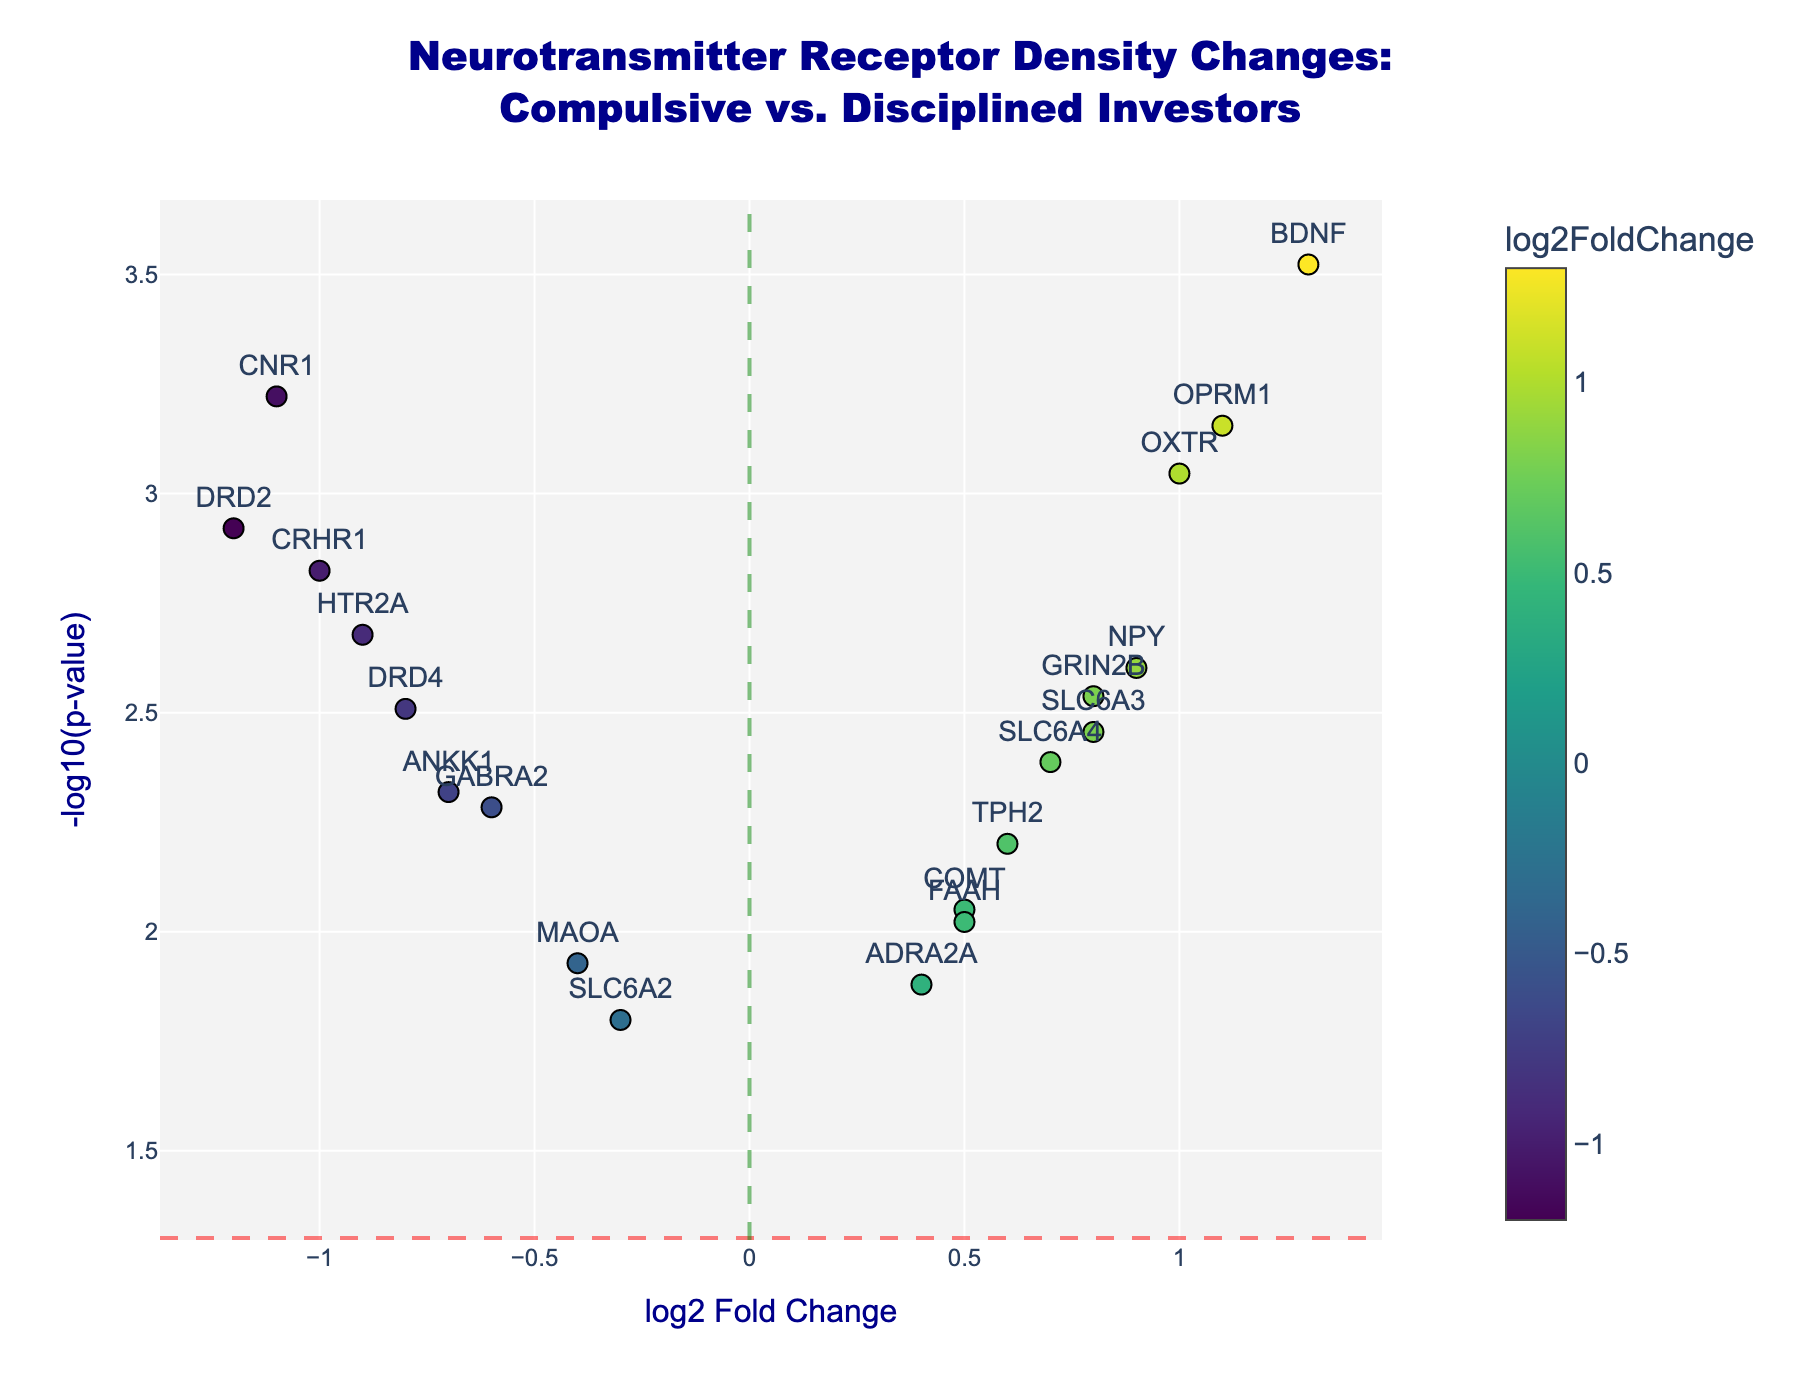What is the title of the figure? The title is stated at the top and is clearly visible. It reads: "Neurotransmitter Receptor Density Changes: Compulsive vs. Disciplined Investors."
Answer: Neurotransmitter Receptor Density Changes: Compulsive vs. Disciplined Investors Which axis represents the log2 Fold Change? The x-axis is labeled as "log2 Fold Change," indicating it represents this value.
Answer: x-axis How many genes have a positive log2 Fold Change? By observing the points to the right of the green vertical line (x=0), we can count the genes with positive values.
Answer: 10 Which gene has the highest log2 Fold Change value? The gene with the point furthest to the right on the x-axis and highest positive log2 Fold Change is BDNF.
Answer: BDNF Which gene has the lowest p-value? The gene with the highest value on the y-axis (-log10(p-value)) has the lowest p-value. This gene is BDNF.
Answer: BDNF What is the log2 Fold Change and p-value for the gene DRD2? By looking at the hover text or position for the gene labeled DRD2, we find the log2 Fold Change is -1.2 and the p-value is 0.0012.
Answer: log2 Fold Change: -1.2, p-value: 0.0012 How many genes are significantly different at a p-value threshold of 0.05? Significantly different genes appear above the red horizontal line (-log10(0.05) ≈ 1.301). Count these genes.
Answer: 18 Which genes have a log2 Fold Change greater than 1? By identifying genes positioned to the right of the x-value 1, we see the labels of these genes: OPRM1, BDNF, OXTR.
Answer: OPRM1, BDNF, OXTR Which gene has a log2 Fold Change of approximately -1 and a p-value very near 0.0015? The gene near -1 on the x-axis and a little above the horizontal line derived from -log10(0.0015) is CRHR1.
Answer: CRHR1 What do the colors of the data points represent in the plot? The color bar on the right indicates that the colors represent the log2 Fold Change values, transitioning according to the Viridis scale.
Answer: log2 Fold Change 